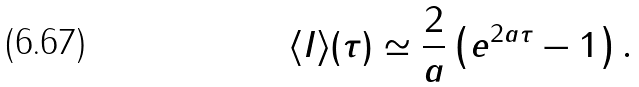Convert formula to latex. <formula><loc_0><loc_0><loc_500><loc_500>\langle I \rangle ( \tau ) \simeq \frac { 2 } { a } \left ( e ^ { 2 a \tau } - 1 \right ) .</formula> 